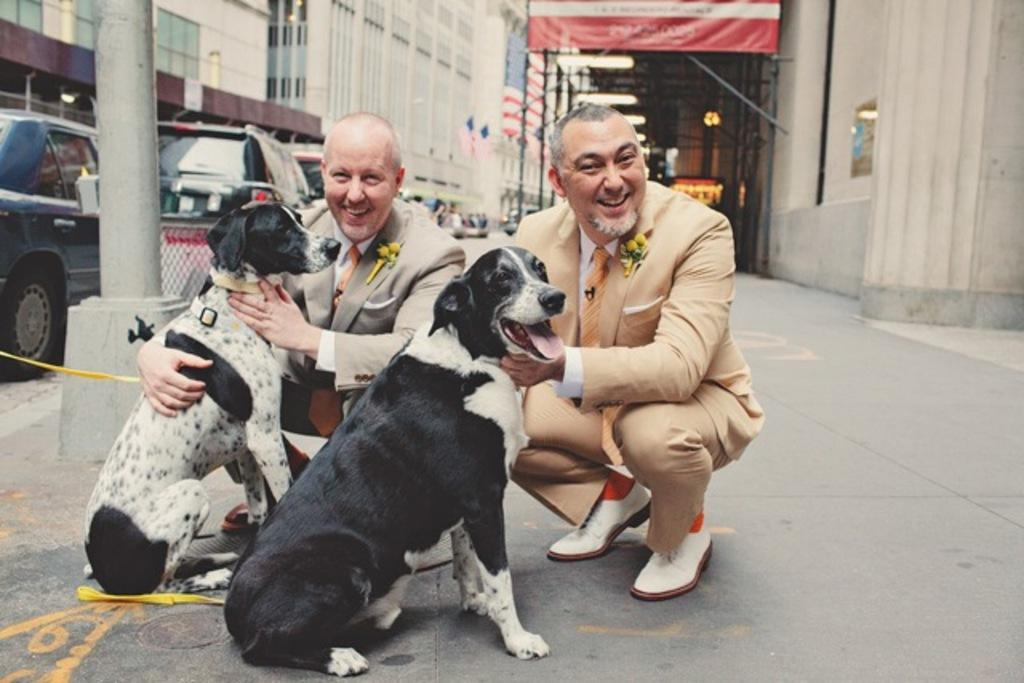How many people are in the image? There are two guys in the image. What are the guys doing in the image? The guys are holding two dogs. Can you describe the dogs in the image? One dog is white, and the other is black. What can be seen in the background of the image? There are many cars and buildings in the background of the image. Where was the image taken? The image was taken on a road. Are the guys in the image wearing suits? There is no information about the guys' clothing in the image, so we cannot determine if they are wearing suits. Can you tell me how the dogs are helping the guys in the image? There is no indication in the image that the dogs are helping the guys in any way. 